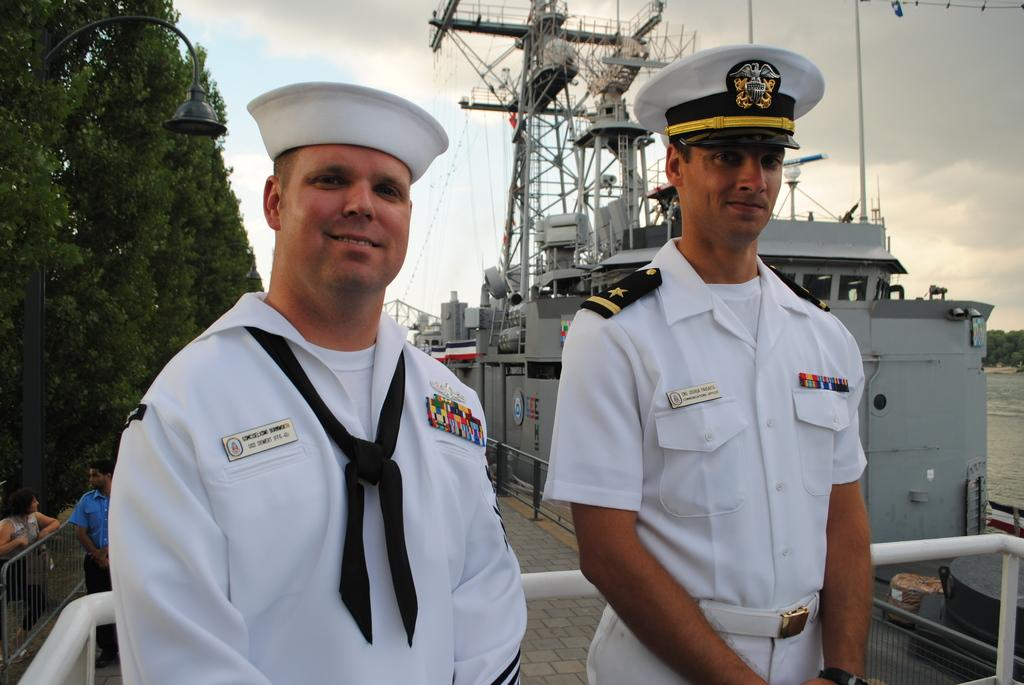How many officers are in the image? There are two officers in the image. What are the officers wearing? The officers are wearing white dress and white caps. What are the officers doing in the image? The officers are standing. What can be seen on the left side of the image? There are trees on the left side of the image. What can be seen on the right side of the image? There is a ship in the sea on the right side of the image. What is visible in the sky in the image? The sky is visible in the image, and clouds are present. What type of butter is being used by the officers in the image? There is no butter present in the image; the officers are wearing white dress and white caps. How many oranges are being held by the officers in the image? There are no oranges present in the image; the officers are not holding any fruits. 